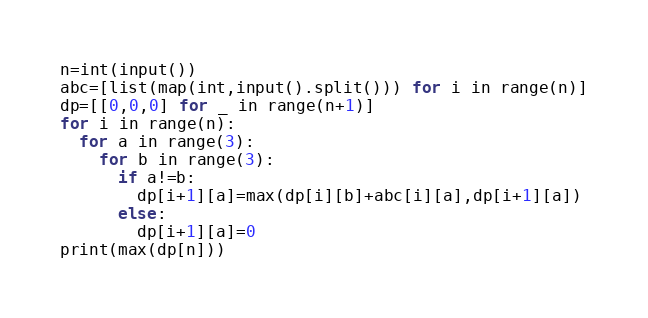Convert code to text. <code><loc_0><loc_0><loc_500><loc_500><_Python_>n=int(input())
abc=[list(map(int,input().split())) for i in range(n)]
dp=[[0,0,0] for _ in range(n+1)]
for i in range(n):
  for a in range(3):
    for b in range(3):
      if a!=b:
        dp[i+1][a]=max(dp[i][b]+abc[i][a],dp[i+1][a])
      else:
        dp[i+1][a]=0
print(max(dp[n]))</code> 